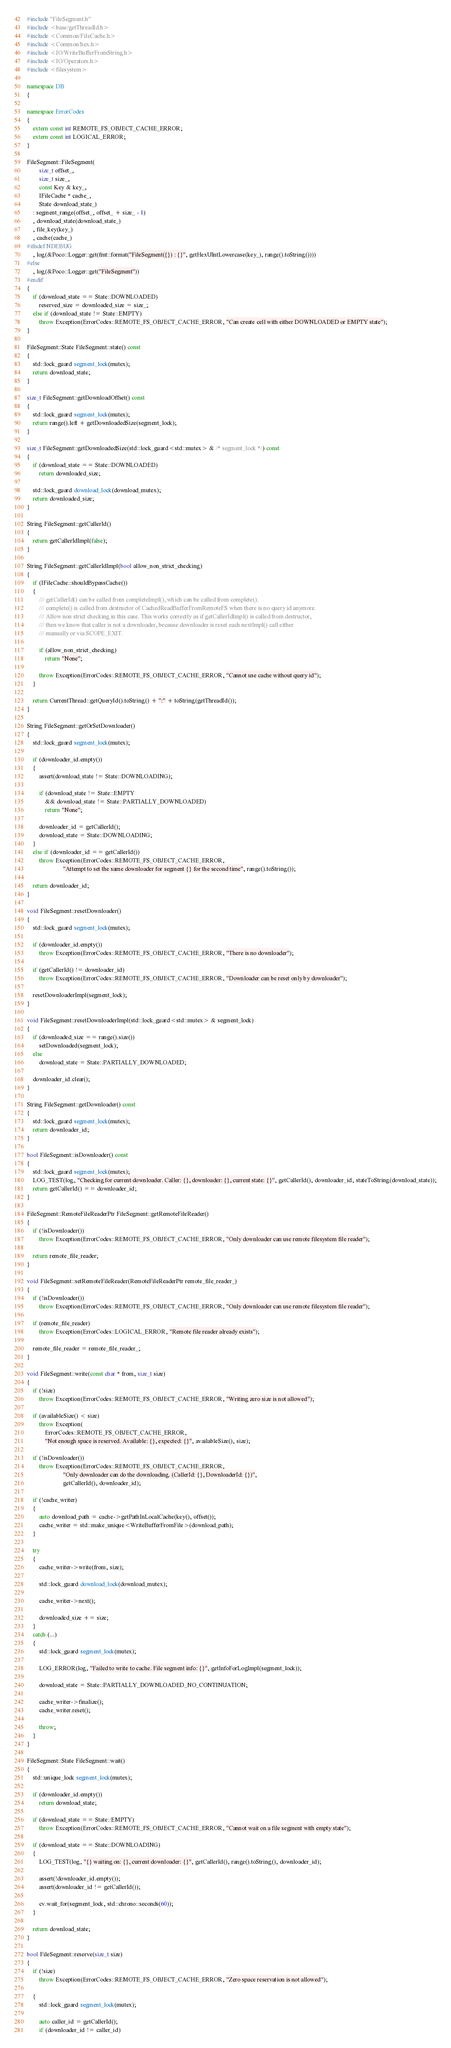Convert code to text. <code><loc_0><loc_0><loc_500><loc_500><_C++_>#include "FileSegment.h"
#include <base/getThreadId.h>
#include <Common/FileCache.h>
#include <Common/hex.h>
#include <IO/WriteBufferFromString.h>
#include <IO/Operators.h>
#include <filesystem>

namespace DB
{

namespace ErrorCodes
{
    extern const int REMOTE_FS_OBJECT_CACHE_ERROR;
    extern const int LOGICAL_ERROR;
}

FileSegment::FileSegment(
        size_t offset_,
        size_t size_,
        const Key & key_,
        IFileCache * cache_,
        State download_state_)
    : segment_range(offset_, offset_ + size_ - 1)
    , download_state(download_state_)
    , file_key(key_)
    , cache(cache_)
#ifndef NDEBUG
    , log(&Poco::Logger::get(fmt::format("FileSegment({}) : {}", getHexUIntLowercase(key_), range().toString())))
#else
    , log(&Poco::Logger::get("FileSegment"))
#endif
{
    if (download_state == State::DOWNLOADED)
        reserved_size = downloaded_size = size_;
    else if (download_state != State::EMPTY)
        throw Exception(ErrorCodes::REMOTE_FS_OBJECT_CACHE_ERROR, "Can create cell with either DOWNLOADED or EMPTY state");
}

FileSegment::State FileSegment::state() const
{
    std::lock_guard segment_lock(mutex);
    return download_state;
}

size_t FileSegment::getDownloadOffset() const
{
    std::lock_guard segment_lock(mutex);
    return range().left + getDownloadedSize(segment_lock);
}

size_t FileSegment::getDownloadedSize(std::lock_guard<std::mutex> & /* segment_lock */) const
{
    if (download_state == State::DOWNLOADED)
        return downloaded_size;

    std::lock_guard download_lock(download_mutex);
    return downloaded_size;
}

String FileSegment::getCallerId()
{
    return getCallerIdImpl(false);
}

String FileSegment::getCallerIdImpl(bool allow_non_strict_checking)
{
    if (IFileCache::shouldBypassCache())
    {
        /// getCallerId() can be called from completeImpl(), which can be called from complete().
        /// complete() is called from destructor of CachedReadBufferFromRemoteFS when there is no query id anymore.
        /// Allow non strict checking in this case. This works correctly as if getCallerIdImpl() is called from destructor,
        /// then we know that caller is not a downloader, because downloader is reset each nextImpl() call either
        /// manually or via SCOPE_EXIT.

        if (allow_non_strict_checking)
            return "None";

        throw Exception(ErrorCodes::REMOTE_FS_OBJECT_CACHE_ERROR, "Cannot use cache without query id");
    }

    return CurrentThread::getQueryId().toString() + ":" + toString(getThreadId());
}

String FileSegment::getOrSetDownloader()
{
    std::lock_guard segment_lock(mutex);

    if (downloader_id.empty())
    {
        assert(download_state != State::DOWNLOADING);

        if (download_state != State::EMPTY
            && download_state != State::PARTIALLY_DOWNLOADED)
            return "None";

        downloader_id = getCallerId();
        download_state = State::DOWNLOADING;
    }
    else if (downloader_id == getCallerId())
        throw Exception(ErrorCodes::REMOTE_FS_OBJECT_CACHE_ERROR,
                        "Attempt to set the same downloader for segment {} for the second time", range().toString());

    return downloader_id;
}

void FileSegment::resetDownloader()
{
    std::lock_guard segment_lock(mutex);

    if (downloader_id.empty())
        throw Exception(ErrorCodes::REMOTE_FS_OBJECT_CACHE_ERROR, "There is no downloader");

    if (getCallerId() != downloader_id)
        throw Exception(ErrorCodes::REMOTE_FS_OBJECT_CACHE_ERROR, "Downloader can be reset only by downloader");

    resetDownloaderImpl(segment_lock);
}

void FileSegment::resetDownloaderImpl(std::lock_guard<std::mutex> & segment_lock)
{
    if (downloaded_size == range().size())
        setDownloaded(segment_lock);
    else
        download_state = State::PARTIALLY_DOWNLOADED;

    downloader_id.clear();
}

String FileSegment::getDownloader() const
{
    std::lock_guard segment_lock(mutex);
    return downloader_id;
}

bool FileSegment::isDownloader() const
{
    std::lock_guard segment_lock(mutex);
    LOG_TEST(log, "Checking for current downloader. Caller: {}, downloader: {}, current state: {}", getCallerId(), downloader_id, stateToString(download_state));
    return getCallerId() == downloader_id;
}

FileSegment::RemoteFileReaderPtr FileSegment::getRemoteFileReader()
{
    if (!isDownloader())
        throw Exception(ErrorCodes::REMOTE_FS_OBJECT_CACHE_ERROR, "Only downloader can use remote filesystem file reader");

    return remote_file_reader;
}

void FileSegment::setRemoteFileReader(RemoteFileReaderPtr remote_file_reader_)
{
    if (!isDownloader())
        throw Exception(ErrorCodes::REMOTE_FS_OBJECT_CACHE_ERROR, "Only downloader can use remote filesystem file reader");

    if (remote_file_reader)
        throw Exception(ErrorCodes::LOGICAL_ERROR, "Remote file reader already exists");

    remote_file_reader = remote_file_reader_;
}

void FileSegment::write(const char * from, size_t size)
{
    if (!size)
        throw Exception(ErrorCodes::REMOTE_FS_OBJECT_CACHE_ERROR, "Writing zero size is not allowed");

    if (availableSize() < size)
        throw Exception(
            ErrorCodes::REMOTE_FS_OBJECT_CACHE_ERROR,
            "Not enough space is reserved. Available: {}, expected: {}", availableSize(), size);

    if (!isDownloader())
        throw Exception(ErrorCodes::REMOTE_FS_OBJECT_CACHE_ERROR,
                        "Only downloader can do the downloading. (CallerId: {}, DownloaderId: {})",
                        getCallerId(), downloader_id);

    if (!cache_writer)
    {
        auto download_path = cache->getPathInLocalCache(key(), offset());
        cache_writer = std::make_unique<WriteBufferFromFile>(download_path);
    }

    try
    {
        cache_writer->write(from, size);

        std::lock_guard download_lock(download_mutex);

        cache_writer->next();

        downloaded_size += size;
    }
    catch (...)
    {
        std::lock_guard segment_lock(mutex);

        LOG_ERROR(log, "Failed to write to cache. File segment info: {}", getInfoForLogImpl(segment_lock));

        download_state = State::PARTIALLY_DOWNLOADED_NO_CONTINUATION;

        cache_writer->finalize();
        cache_writer.reset();

        throw;
    }
}

FileSegment::State FileSegment::wait()
{
    std::unique_lock segment_lock(mutex);

    if (downloader_id.empty())
        return download_state;

    if (download_state == State::EMPTY)
        throw Exception(ErrorCodes::REMOTE_FS_OBJECT_CACHE_ERROR, "Cannot wait on a file segment with empty state");

    if (download_state == State::DOWNLOADING)
    {
        LOG_TEST(log, "{} waiting on: {}, current downloader: {}", getCallerId(), range().toString(), downloader_id);

        assert(!downloader_id.empty());
        assert(downloader_id != getCallerId());

        cv.wait_for(segment_lock, std::chrono::seconds(60));
    }

    return download_state;
}

bool FileSegment::reserve(size_t size)
{
    if (!size)
        throw Exception(ErrorCodes::REMOTE_FS_OBJECT_CACHE_ERROR, "Zero space reservation is not allowed");

    {
        std::lock_guard segment_lock(mutex);

        auto caller_id = getCallerId();
        if (downloader_id != caller_id)</code> 